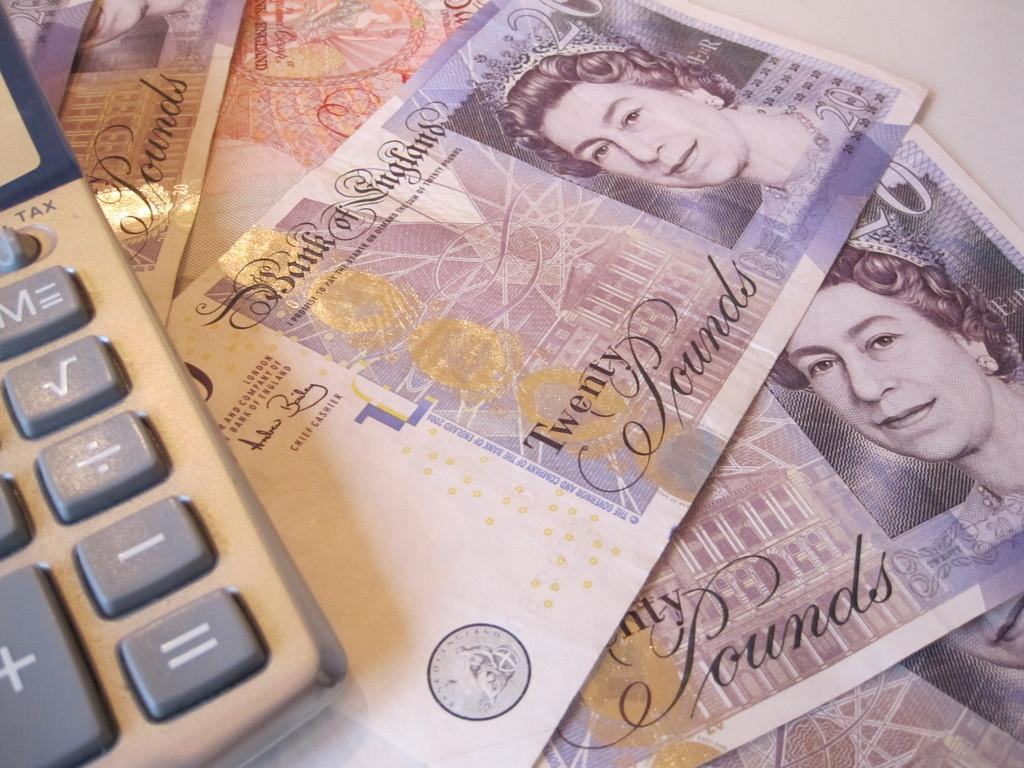What type of object is present in the image that is related to finance or money? The image contains currency of some country. What device can be seen on the left side of the image? There is a calculator on the left side of the image. What time does the clock show in the image? There is: There is no clock present in the image. How many clouds can be seen in the image? There are no clouds visible in the image. 